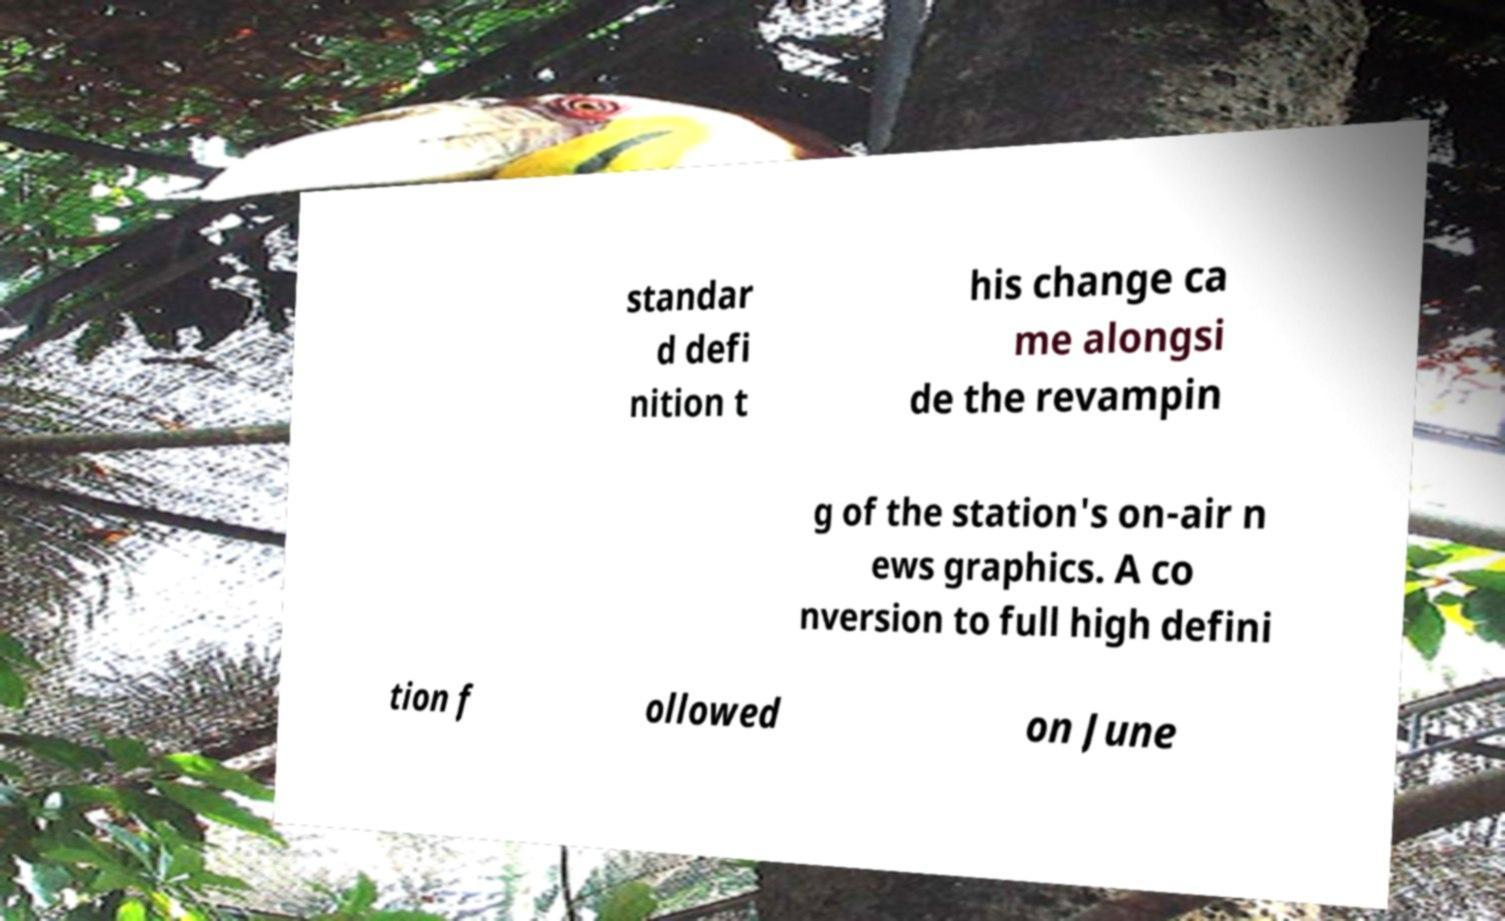Can you accurately transcribe the text from the provided image for me? standar d defi nition t his change ca me alongsi de the revampin g of the station's on-air n ews graphics. A co nversion to full high defini tion f ollowed on June 